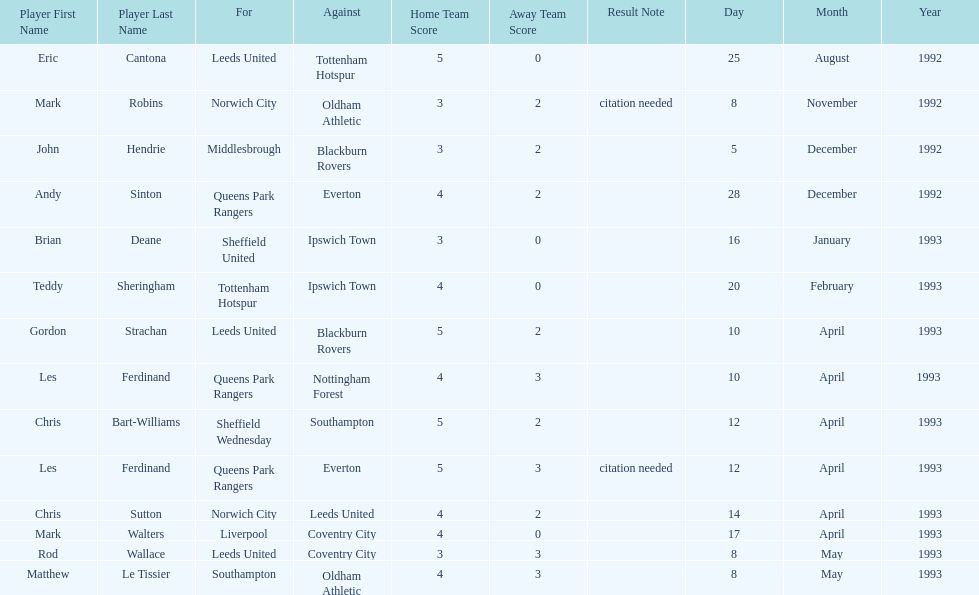Who does john hendrie play for? Middlesbrough. 